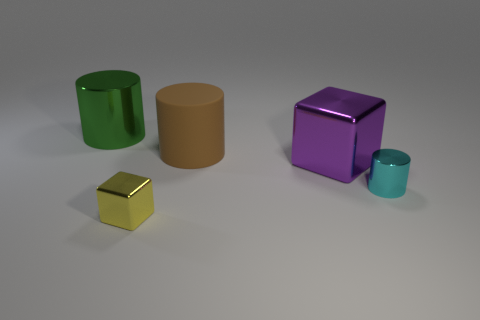Add 3 brown rubber cylinders. How many objects exist? 8 Subtract all cubes. How many objects are left? 3 Add 1 tiny objects. How many tiny objects exist? 3 Subtract 0 red spheres. How many objects are left? 5 Subtract all tiny cylinders. Subtract all tiny cylinders. How many objects are left? 3 Add 3 tiny metal cylinders. How many tiny metal cylinders are left? 4 